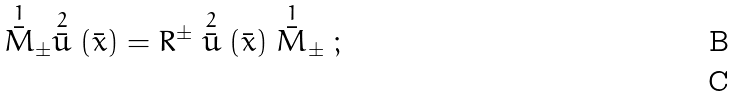<formula> <loc_0><loc_0><loc_500><loc_500>\stackrel { 1 } { \bar { M } } _ { \pm } \stackrel { 2 } { \bar { u } } ( \bar { x } ) = R ^ { \pm } \stackrel { 2 } { \bar { u } } ( \bar { x } ) \stackrel { 1 } { \bar { M } } _ { \pm } \ ; \\</formula> 